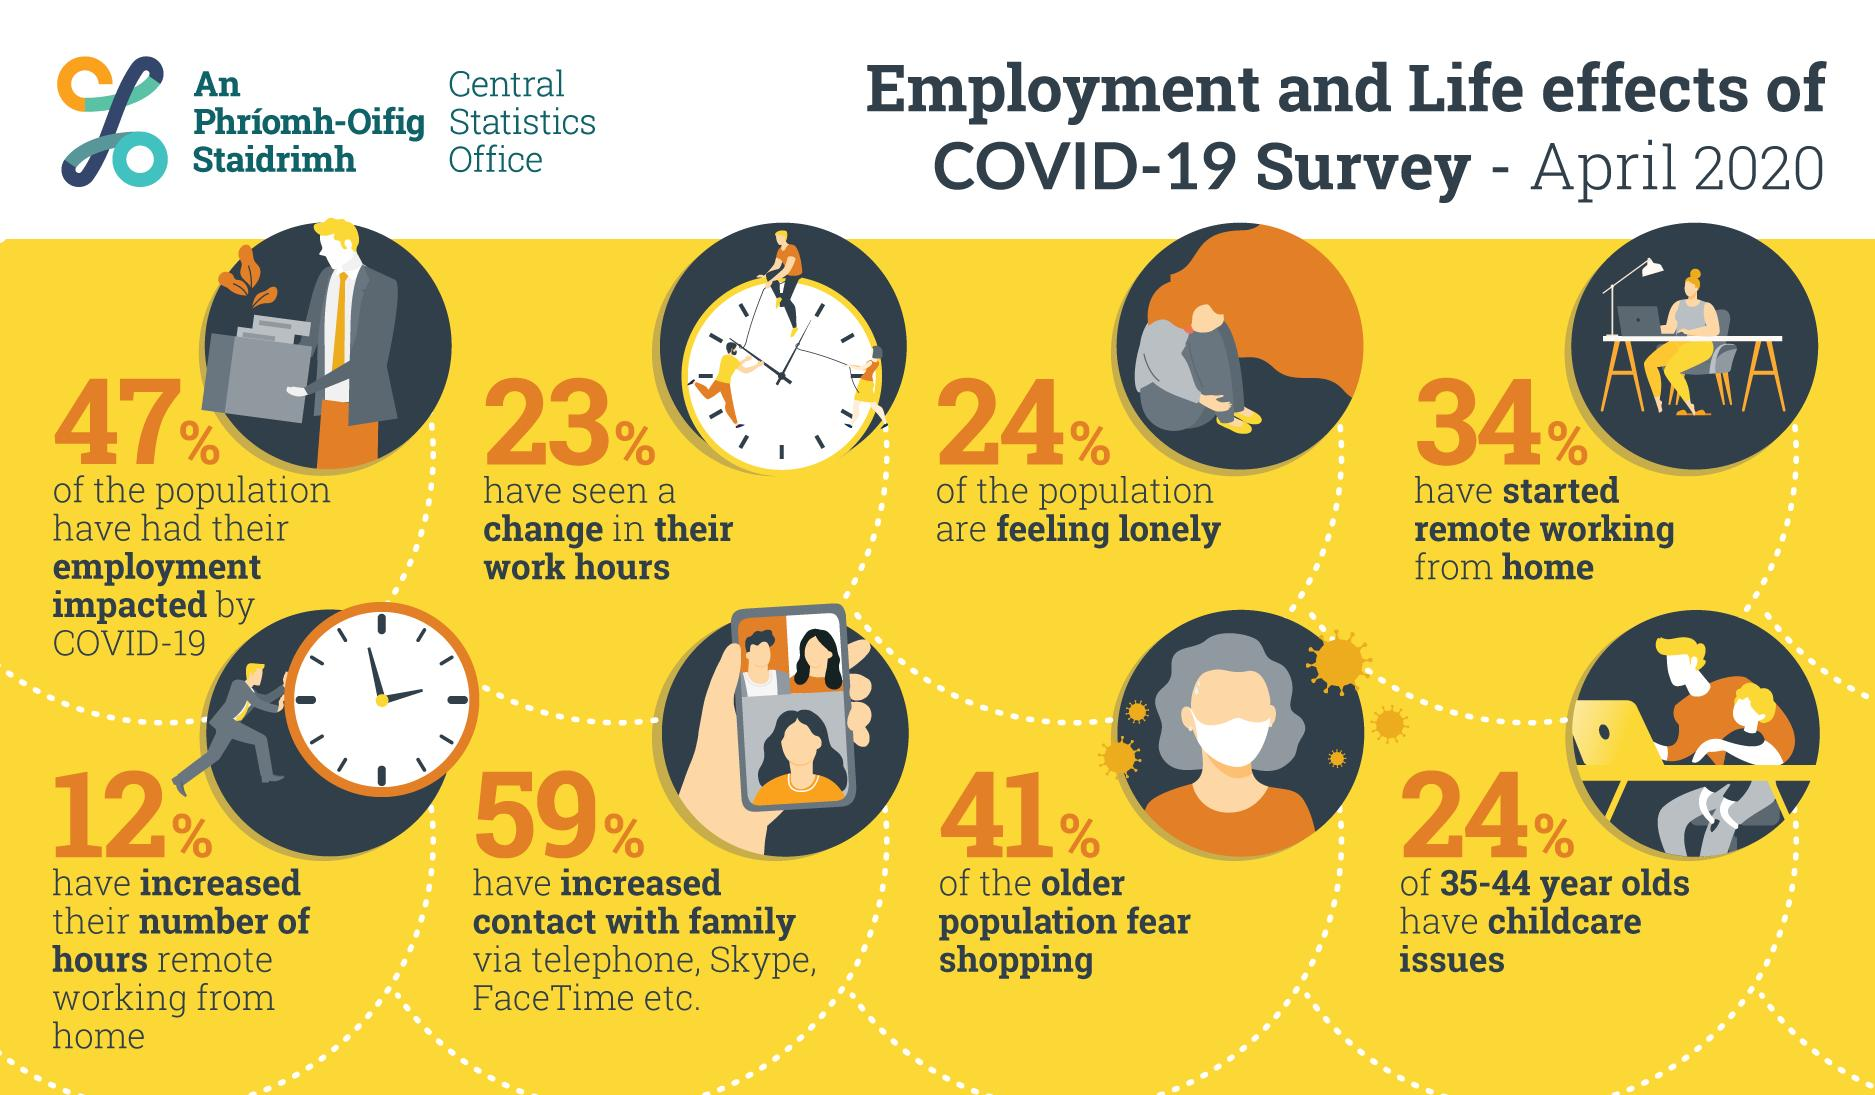Give some essential details in this illustration. Among those surveyed, 76% reported not feeling lonely. The color of the mask that one of the avatars is wearing in this infographic is white. According to the data, among individuals aged 35-44, approximately 24% are facing childcare challenges. According to a survey of the older population, 41% fear shopping. According to the survey results, approximately 24% of people report feeling lonely. 